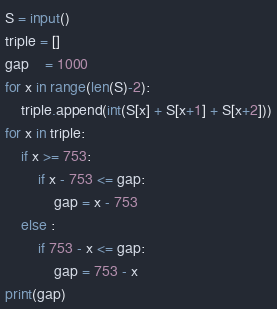<code> <loc_0><loc_0><loc_500><loc_500><_Python_>S = input()
triple = []
gap    = 1000
for x in range(len(S)-2):
    triple.append(int(S[x] + S[x+1] + S[x+2]))
for x in triple:
    if x >= 753:
        if x - 753 <= gap:
            gap = x - 753
    else :
        if 753 - x <= gap:
            gap = 753 - x
print(gap)</code> 